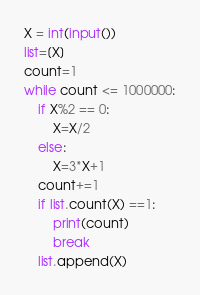Convert code to text. <code><loc_0><loc_0><loc_500><loc_500><_Python_>X = int(input())
list=[X]
count=1
while count <= 1000000:
    if X%2 == 0:
        X=X/2
    else:
        X=3*X+1
    count+=1
    if list.count(X) ==1:
        print(count)
        break
    list.append(X)</code> 